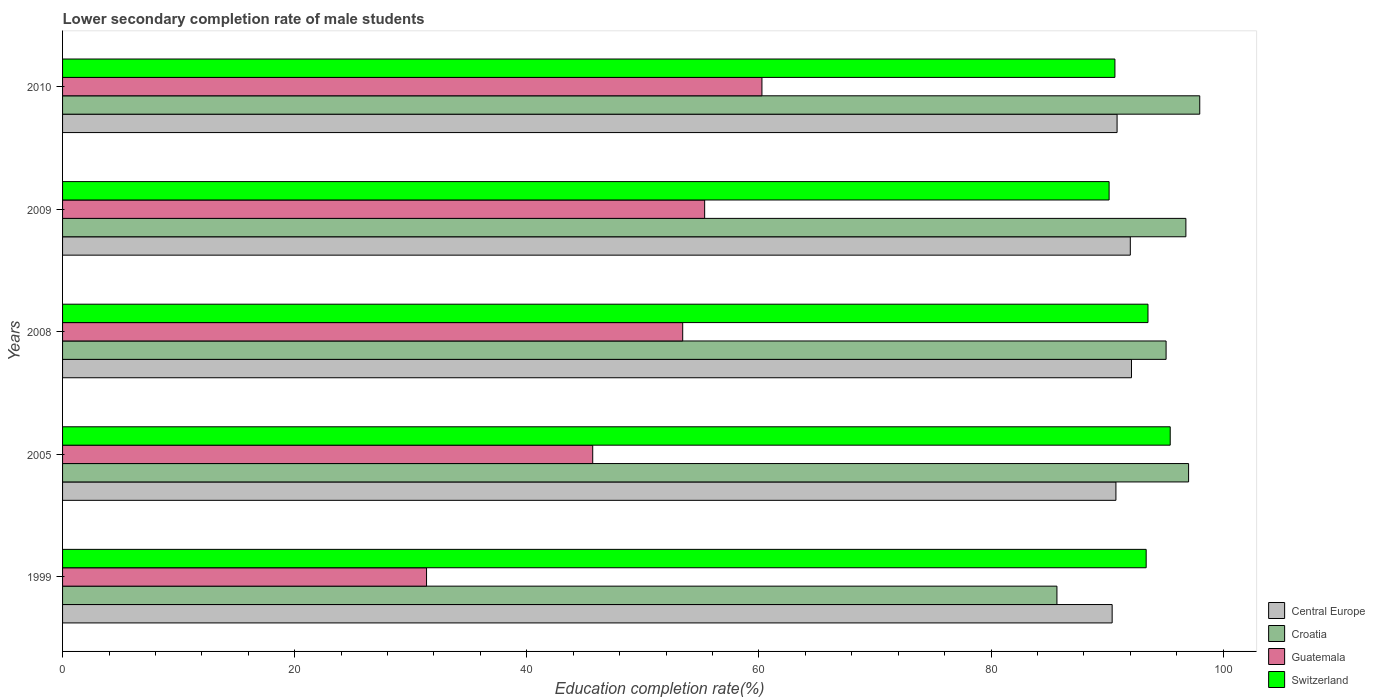How many groups of bars are there?
Your response must be concise. 5. Are the number of bars per tick equal to the number of legend labels?
Offer a terse response. Yes. How many bars are there on the 4th tick from the bottom?
Ensure brevity in your answer.  4. In how many cases, is the number of bars for a given year not equal to the number of legend labels?
Provide a short and direct response. 0. What is the lower secondary completion rate of male students in Switzerland in 2005?
Provide a succinct answer. 95.43. Across all years, what is the maximum lower secondary completion rate of male students in Croatia?
Provide a succinct answer. 97.98. Across all years, what is the minimum lower secondary completion rate of male students in Croatia?
Make the answer very short. 85.67. What is the total lower secondary completion rate of male students in Switzerland in the graph?
Ensure brevity in your answer.  463.14. What is the difference between the lower secondary completion rate of male students in Central Europe in 2009 and that in 2010?
Provide a short and direct response. 1.14. What is the difference between the lower secondary completion rate of male students in Guatemala in 2010 and the lower secondary completion rate of male students in Central Europe in 2008?
Keep it short and to the point. -31.84. What is the average lower secondary completion rate of male students in Central Europe per year?
Your answer should be very brief. 91.23. In the year 2008, what is the difference between the lower secondary completion rate of male students in Switzerland and lower secondary completion rate of male students in Guatemala?
Make the answer very short. 40.09. In how many years, is the lower secondary completion rate of male students in Croatia greater than 20 %?
Your answer should be compact. 5. What is the ratio of the lower secondary completion rate of male students in Central Europe in 1999 to that in 2005?
Offer a terse response. 1. Is the difference between the lower secondary completion rate of male students in Switzerland in 2005 and 2009 greater than the difference between the lower secondary completion rate of male students in Guatemala in 2005 and 2009?
Your answer should be very brief. Yes. What is the difference between the highest and the second highest lower secondary completion rate of male students in Switzerland?
Make the answer very short. 1.92. What is the difference between the highest and the lowest lower secondary completion rate of male students in Central Europe?
Provide a short and direct response. 1.67. In how many years, is the lower secondary completion rate of male students in Guatemala greater than the average lower secondary completion rate of male students in Guatemala taken over all years?
Make the answer very short. 3. Is the sum of the lower secondary completion rate of male students in Switzerland in 2005 and 2010 greater than the maximum lower secondary completion rate of male students in Guatemala across all years?
Your response must be concise. Yes. Is it the case that in every year, the sum of the lower secondary completion rate of male students in Croatia and lower secondary completion rate of male students in Guatemala is greater than the sum of lower secondary completion rate of male students in Switzerland and lower secondary completion rate of male students in Central Europe?
Offer a very short reply. Yes. What does the 1st bar from the top in 2005 represents?
Your answer should be very brief. Switzerland. What does the 4th bar from the bottom in 2008 represents?
Ensure brevity in your answer.  Switzerland. How many bars are there?
Keep it short and to the point. 20. How many years are there in the graph?
Keep it short and to the point. 5. What is the difference between two consecutive major ticks on the X-axis?
Give a very brief answer. 20. Does the graph contain any zero values?
Offer a terse response. No. Does the graph contain grids?
Your answer should be compact. No. How many legend labels are there?
Your response must be concise. 4. How are the legend labels stacked?
Give a very brief answer. Vertical. What is the title of the graph?
Make the answer very short. Lower secondary completion rate of male students. What is the label or title of the X-axis?
Provide a short and direct response. Education completion rate(%). What is the Education completion rate(%) in Central Europe in 1999?
Ensure brevity in your answer.  90.43. What is the Education completion rate(%) of Croatia in 1999?
Make the answer very short. 85.67. What is the Education completion rate(%) of Guatemala in 1999?
Your answer should be very brief. 31.36. What is the Education completion rate(%) of Switzerland in 1999?
Provide a succinct answer. 93.36. What is the Education completion rate(%) of Central Europe in 2005?
Provide a succinct answer. 90.75. What is the Education completion rate(%) of Croatia in 2005?
Provide a short and direct response. 97.02. What is the Education completion rate(%) of Guatemala in 2005?
Keep it short and to the point. 45.68. What is the Education completion rate(%) of Switzerland in 2005?
Ensure brevity in your answer.  95.43. What is the Education completion rate(%) in Central Europe in 2008?
Provide a short and direct response. 92.1. What is the Education completion rate(%) of Croatia in 2008?
Your response must be concise. 95.08. What is the Education completion rate(%) in Guatemala in 2008?
Your answer should be very brief. 53.43. What is the Education completion rate(%) of Switzerland in 2008?
Make the answer very short. 93.52. What is the Education completion rate(%) in Central Europe in 2009?
Keep it short and to the point. 91.99. What is the Education completion rate(%) of Croatia in 2009?
Give a very brief answer. 96.78. What is the Education completion rate(%) in Guatemala in 2009?
Ensure brevity in your answer.  55.32. What is the Education completion rate(%) in Switzerland in 2009?
Ensure brevity in your answer.  90.17. What is the Education completion rate(%) in Central Europe in 2010?
Give a very brief answer. 90.85. What is the Education completion rate(%) in Croatia in 2010?
Your answer should be compact. 97.98. What is the Education completion rate(%) of Guatemala in 2010?
Ensure brevity in your answer.  60.26. What is the Education completion rate(%) of Switzerland in 2010?
Give a very brief answer. 90.67. Across all years, what is the maximum Education completion rate(%) of Central Europe?
Provide a short and direct response. 92.1. Across all years, what is the maximum Education completion rate(%) in Croatia?
Give a very brief answer. 97.98. Across all years, what is the maximum Education completion rate(%) of Guatemala?
Make the answer very short. 60.26. Across all years, what is the maximum Education completion rate(%) of Switzerland?
Keep it short and to the point. 95.43. Across all years, what is the minimum Education completion rate(%) in Central Europe?
Ensure brevity in your answer.  90.43. Across all years, what is the minimum Education completion rate(%) of Croatia?
Provide a succinct answer. 85.67. Across all years, what is the minimum Education completion rate(%) of Guatemala?
Give a very brief answer. 31.36. Across all years, what is the minimum Education completion rate(%) in Switzerland?
Keep it short and to the point. 90.17. What is the total Education completion rate(%) of Central Europe in the graph?
Offer a terse response. 456.13. What is the total Education completion rate(%) in Croatia in the graph?
Offer a terse response. 472.52. What is the total Education completion rate(%) of Guatemala in the graph?
Make the answer very short. 246.04. What is the total Education completion rate(%) in Switzerland in the graph?
Make the answer very short. 463.14. What is the difference between the Education completion rate(%) of Central Europe in 1999 and that in 2005?
Offer a very short reply. -0.32. What is the difference between the Education completion rate(%) of Croatia in 1999 and that in 2005?
Your response must be concise. -11.34. What is the difference between the Education completion rate(%) in Guatemala in 1999 and that in 2005?
Your answer should be very brief. -14.32. What is the difference between the Education completion rate(%) of Switzerland in 1999 and that in 2005?
Give a very brief answer. -2.07. What is the difference between the Education completion rate(%) of Central Europe in 1999 and that in 2008?
Provide a short and direct response. -1.67. What is the difference between the Education completion rate(%) in Croatia in 1999 and that in 2008?
Offer a very short reply. -9.4. What is the difference between the Education completion rate(%) in Guatemala in 1999 and that in 2008?
Your answer should be very brief. -22.07. What is the difference between the Education completion rate(%) of Switzerland in 1999 and that in 2008?
Provide a succinct answer. -0.16. What is the difference between the Education completion rate(%) in Central Europe in 1999 and that in 2009?
Your response must be concise. -1.56. What is the difference between the Education completion rate(%) of Croatia in 1999 and that in 2009?
Your answer should be compact. -11.11. What is the difference between the Education completion rate(%) of Guatemala in 1999 and that in 2009?
Make the answer very short. -23.96. What is the difference between the Education completion rate(%) in Switzerland in 1999 and that in 2009?
Provide a short and direct response. 3.19. What is the difference between the Education completion rate(%) of Central Europe in 1999 and that in 2010?
Provide a short and direct response. -0.42. What is the difference between the Education completion rate(%) in Croatia in 1999 and that in 2010?
Offer a very short reply. -12.3. What is the difference between the Education completion rate(%) of Guatemala in 1999 and that in 2010?
Your answer should be compact. -28.9. What is the difference between the Education completion rate(%) in Switzerland in 1999 and that in 2010?
Give a very brief answer. 2.69. What is the difference between the Education completion rate(%) of Central Europe in 2005 and that in 2008?
Your answer should be very brief. -1.34. What is the difference between the Education completion rate(%) in Croatia in 2005 and that in 2008?
Provide a succinct answer. 1.94. What is the difference between the Education completion rate(%) in Guatemala in 2005 and that in 2008?
Your answer should be compact. -7.75. What is the difference between the Education completion rate(%) in Switzerland in 2005 and that in 2008?
Your answer should be very brief. 1.92. What is the difference between the Education completion rate(%) of Central Europe in 2005 and that in 2009?
Make the answer very short. -1.24. What is the difference between the Education completion rate(%) of Croatia in 2005 and that in 2009?
Provide a short and direct response. 0.23. What is the difference between the Education completion rate(%) of Guatemala in 2005 and that in 2009?
Provide a succinct answer. -9.64. What is the difference between the Education completion rate(%) in Switzerland in 2005 and that in 2009?
Ensure brevity in your answer.  5.27. What is the difference between the Education completion rate(%) in Central Europe in 2005 and that in 2010?
Your answer should be very brief. -0.1. What is the difference between the Education completion rate(%) of Croatia in 2005 and that in 2010?
Keep it short and to the point. -0.96. What is the difference between the Education completion rate(%) of Guatemala in 2005 and that in 2010?
Your answer should be compact. -14.58. What is the difference between the Education completion rate(%) of Switzerland in 2005 and that in 2010?
Your answer should be compact. 4.76. What is the difference between the Education completion rate(%) in Central Europe in 2008 and that in 2009?
Give a very brief answer. 0.1. What is the difference between the Education completion rate(%) of Croatia in 2008 and that in 2009?
Offer a very short reply. -1.71. What is the difference between the Education completion rate(%) of Guatemala in 2008 and that in 2009?
Provide a succinct answer. -1.89. What is the difference between the Education completion rate(%) of Switzerland in 2008 and that in 2009?
Offer a very short reply. 3.35. What is the difference between the Education completion rate(%) in Central Europe in 2008 and that in 2010?
Give a very brief answer. 1.24. What is the difference between the Education completion rate(%) in Croatia in 2008 and that in 2010?
Keep it short and to the point. -2.9. What is the difference between the Education completion rate(%) of Guatemala in 2008 and that in 2010?
Your response must be concise. -6.83. What is the difference between the Education completion rate(%) in Switzerland in 2008 and that in 2010?
Make the answer very short. 2.85. What is the difference between the Education completion rate(%) in Central Europe in 2009 and that in 2010?
Keep it short and to the point. 1.14. What is the difference between the Education completion rate(%) in Croatia in 2009 and that in 2010?
Make the answer very short. -1.19. What is the difference between the Education completion rate(%) of Guatemala in 2009 and that in 2010?
Ensure brevity in your answer.  -4.94. What is the difference between the Education completion rate(%) in Switzerland in 2009 and that in 2010?
Offer a very short reply. -0.5. What is the difference between the Education completion rate(%) in Central Europe in 1999 and the Education completion rate(%) in Croatia in 2005?
Keep it short and to the point. -6.59. What is the difference between the Education completion rate(%) in Central Europe in 1999 and the Education completion rate(%) in Guatemala in 2005?
Your answer should be very brief. 44.75. What is the difference between the Education completion rate(%) in Central Europe in 1999 and the Education completion rate(%) in Switzerland in 2005?
Ensure brevity in your answer.  -5. What is the difference between the Education completion rate(%) in Croatia in 1999 and the Education completion rate(%) in Guatemala in 2005?
Your response must be concise. 40. What is the difference between the Education completion rate(%) in Croatia in 1999 and the Education completion rate(%) in Switzerland in 2005?
Keep it short and to the point. -9.76. What is the difference between the Education completion rate(%) of Guatemala in 1999 and the Education completion rate(%) of Switzerland in 2005?
Provide a short and direct response. -64.07. What is the difference between the Education completion rate(%) in Central Europe in 1999 and the Education completion rate(%) in Croatia in 2008?
Offer a terse response. -4.65. What is the difference between the Education completion rate(%) in Central Europe in 1999 and the Education completion rate(%) in Guatemala in 2008?
Your answer should be very brief. 37. What is the difference between the Education completion rate(%) of Central Europe in 1999 and the Education completion rate(%) of Switzerland in 2008?
Offer a terse response. -3.09. What is the difference between the Education completion rate(%) of Croatia in 1999 and the Education completion rate(%) of Guatemala in 2008?
Make the answer very short. 32.24. What is the difference between the Education completion rate(%) in Croatia in 1999 and the Education completion rate(%) in Switzerland in 2008?
Provide a short and direct response. -7.84. What is the difference between the Education completion rate(%) of Guatemala in 1999 and the Education completion rate(%) of Switzerland in 2008?
Offer a terse response. -62.16. What is the difference between the Education completion rate(%) of Central Europe in 1999 and the Education completion rate(%) of Croatia in 2009?
Give a very brief answer. -6.35. What is the difference between the Education completion rate(%) in Central Europe in 1999 and the Education completion rate(%) in Guatemala in 2009?
Provide a short and direct response. 35.11. What is the difference between the Education completion rate(%) of Central Europe in 1999 and the Education completion rate(%) of Switzerland in 2009?
Give a very brief answer. 0.26. What is the difference between the Education completion rate(%) in Croatia in 1999 and the Education completion rate(%) in Guatemala in 2009?
Keep it short and to the point. 30.35. What is the difference between the Education completion rate(%) in Croatia in 1999 and the Education completion rate(%) in Switzerland in 2009?
Your answer should be very brief. -4.49. What is the difference between the Education completion rate(%) in Guatemala in 1999 and the Education completion rate(%) in Switzerland in 2009?
Your response must be concise. -58.81. What is the difference between the Education completion rate(%) of Central Europe in 1999 and the Education completion rate(%) of Croatia in 2010?
Give a very brief answer. -7.55. What is the difference between the Education completion rate(%) of Central Europe in 1999 and the Education completion rate(%) of Guatemala in 2010?
Your answer should be very brief. 30.17. What is the difference between the Education completion rate(%) in Central Europe in 1999 and the Education completion rate(%) in Switzerland in 2010?
Ensure brevity in your answer.  -0.24. What is the difference between the Education completion rate(%) of Croatia in 1999 and the Education completion rate(%) of Guatemala in 2010?
Your answer should be compact. 25.42. What is the difference between the Education completion rate(%) in Croatia in 1999 and the Education completion rate(%) in Switzerland in 2010?
Provide a succinct answer. -5. What is the difference between the Education completion rate(%) in Guatemala in 1999 and the Education completion rate(%) in Switzerland in 2010?
Your answer should be compact. -59.31. What is the difference between the Education completion rate(%) in Central Europe in 2005 and the Education completion rate(%) in Croatia in 2008?
Give a very brief answer. -4.32. What is the difference between the Education completion rate(%) of Central Europe in 2005 and the Education completion rate(%) of Guatemala in 2008?
Offer a very short reply. 37.32. What is the difference between the Education completion rate(%) of Central Europe in 2005 and the Education completion rate(%) of Switzerland in 2008?
Provide a short and direct response. -2.76. What is the difference between the Education completion rate(%) of Croatia in 2005 and the Education completion rate(%) of Guatemala in 2008?
Keep it short and to the point. 43.59. What is the difference between the Education completion rate(%) in Croatia in 2005 and the Education completion rate(%) in Switzerland in 2008?
Keep it short and to the point. 3.5. What is the difference between the Education completion rate(%) in Guatemala in 2005 and the Education completion rate(%) in Switzerland in 2008?
Give a very brief answer. -47.84. What is the difference between the Education completion rate(%) in Central Europe in 2005 and the Education completion rate(%) in Croatia in 2009?
Your response must be concise. -6.03. What is the difference between the Education completion rate(%) in Central Europe in 2005 and the Education completion rate(%) in Guatemala in 2009?
Provide a short and direct response. 35.43. What is the difference between the Education completion rate(%) in Central Europe in 2005 and the Education completion rate(%) in Switzerland in 2009?
Keep it short and to the point. 0.59. What is the difference between the Education completion rate(%) in Croatia in 2005 and the Education completion rate(%) in Guatemala in 2009?
Offer a very short reply. 41.69. What is the difference between the Education completion rate(%) of Croatia in 2005 and the Education completion rate(%) of Switzerland in 2009?
Your response must be concise. 6.85. What is the difference between the Education completion rate(%) of Guatemala in 2005 and the Education completion rate(%) of Switzerland in 2009?
Your answer should be compact. -44.49. What is the difference between the Education completion rate(%) of Central Europe in 2005 and the Education completion rate(%) of Croatia in 2010?
Offer a very short reply. -7.22. What is the difference between the Education completion rate(%) of Central Europe in 2005 and the Education completion rate(%) of Guatemala in 2010?
Your answer should be compact. 30.5. What is the difference between the Education completion rate(%) of Central Europe in 2005 and the Education completion rate(%) of Switzerland in 2010?
Give a very brief answer. 0.09. What is the difference between the Education completion rate(%) in Croatia in 2005 and the Education completion rate(%) in Guatemala in 2010?
Make the answer very short. 36.76. What is the difference between the Education completion rate(%) in Croatia in 2005 and the Education completion rate(%) in Switzerland in 2010?
Make the answer very short. 6.35. What is the difference between the Education completion rate(%) of Guatemala in 2005 and the Education completion rate(%) of Switzerland in 2010?
Your response must be concise. -44.99. What is the difference between the Education completion rate(%) of Central Europe in 2008 and the Education completion rate(%) of Croatia in 2009?
Provide a short and direct response. -4.69. What is the difference between the Education completion rate(%) of Central Europe in 2008 and the Education completion rate(%) of Guatemala in 2009?
Provide a short and direct response. 36.77. What is the difference between the Education completion rate(%) in Central Europe in 2008 and the Education completion rate(%) in Switzerland in 2009?
Provide a succinct answer. 1.93. What is the difference between the Education completion rate(%) of Croatia in 2008 and the Education completion rate(%) of Guatemala in 2009?
Provide a short and direct response. 39.76. What is the difference between the Education completion rate(%) in Croatia in 2008 and the Education completion rate(%) in Switzerland in 2009?
Give a very brief answer. 4.91. What is the difference between the Education completion rate(%) in Guatemala in 2008 and the Education completion rate(%) in Switzerland in 2009?
Offer a terse response. -36.74. What is the difference between the Education completion rate(%) in Central Europe in 2008 and the Education completion rate(%) in Croatia in 2010?
Provide a succinct answer. -5.88. What is the difference between the Education completion rate(%) in Central Europe in 2008 and the Education completion rate(%) in Guatemala in 2010?
Your answer should be compact. 31.84. What is the difference between the Education completion rate(%) of Central Europe in 2008 and the Education completion rate(%) of Switzerland in 2010?
Your answer should be very brief. 1.43. What is the difference between the Education completion rate(%) of Croatia in 2008 and the Education completion rate(%) of Guatemala in 2010?
Keep it short and to the point. 34.82. What is the difference between the Education completion rate(%) of Croatia in 2008 and the Education completion rate(%) of Switzerland in 2010?
Your answer should be very brief. 4.41. What is the difference between the Education completion rate(%) of Guatemala in 2008 and the Education completion rate(%) of Switzerland in 2010?
Make the answer very short. -37.24. What is the difference between the Education completion rate(%) of Central Europe in 2009 and the Education completion rate(%) of Croatia in 2010?
Give a very brief answer. -5.98. What is the difference between the Education completion rate(%) of Central Europe in 2009 and the Education completion rate(%) of Guatemala in 2010?
Give a very brief answer. 31.74. What is the difference between the Education completion rate(%) in Central Europe in 2009 and the Education completion rate(%) in Switzerland in 2010?
Keep it short and to the point. 1.33. What is the difference between the Education completion rate(%) of Croatia in 2009 and the Education completion rate(%) of Guatemala in 2010?
Offer a very short reply. 36.53. What is the difference between the Education completion rate(%) of Croatia in 2009 and the Education completion rate(%) of Switzerland in 2010?
Your response must be concise. 6.11. What is the difference between the Education completion rate(%) in Guatemala in 2009 and the Education completion rate(%) in Switzerland in 2010?
Keep it short and to the point. -35.35. What is the average Education completion rate(%) of Central Europe per year?
Give a very brief answer. 91.22. What is the average Education completion rate(%) of Croatia per year?
Provide a short and direct response. 94.5. What is the average Education completion rate(%) of Guatemala per year?
Keep it short and to the point. 49.21. What is the average Education completion rate(%) of Switzerland per year?
Offer a terse response. 92.63. In the year 1999, what is the difference between the Education completion rate(%) of Central Europe and Education completion rate(%) of Croatia?
Your response must be concise. 4.76. In the year 1999, what is the difference between the Education completion rate(%) in Central Europe and Education completion rate(%) in Guatemala?
Give a very brief answer. 59.07. In the year 1999, what is the difference between the Education completion rate(%) in Central Europe and Education completion rate(%) in Switzerland?
Offer a terse response. -2.93. In the year 1999, what is the difference between the Education completion rate(%) in Croatia and Education completion rate(%) in Guatemala?
Keep it short and to the point. 54.31. In the year 1999, what is the difference between the Education completion rate(%) of Croatia and Education completion rate(%) of Switzerland?
Make the answer very short. -7.69. In the year 1999, what is the difference between the Education completion rate(%) in Guatemala and Education completion rate(%) in Switzerland?
Your answer should be compact. -62. In the year 2005, what is the difference between the Education completion rate(%) in Central Europe and Education completion rate(%) in Croatia?
Ensure brevity in your answer.  -6.26. In the year 2005, what is the difference between the Education completion rate(%) in Central Europe and Education completion rate(%) in Guatemala?
Offer a terse response. 45.08. In the year 2005, what is the difference between the Education completion rate(%) in Central Europe and Education completion rate(%) in Switzerland?
Your response must be concise. -4.68. In the year 2005, what is the difference between the Education completion rate(%) in Croatia and Education completion rate(%) in Guatemala?
Offer a very short reply. 51.34. In the year 2005, what is the difference between the Education completion rate(%) in Croatia and Education completion rate(%) in Switzerland?
Make the answer very short. 1.58. In the year 2005, what is the difference between the Education completion rate(%) of Guatemala and Education completion rate(%) of Switzerland?
Give a very brief answer. -49.76. In the year 2008, what is the difference between the Education completion rate(%) of Central Europe and Education completion rate(%) of Croatia?
Your response must be concise. -2.98. In the year 2008, what is the difference between the Education completion rate(%) in Central Europe and Education completion rate(%) in Guatemala?
Provide a succinct answer. 38.67. In the year 2008, what is the difference between the Education completion rate(%) of Central Europe and Education completion rate(%) of Switzerland?
Your response must be concise. -1.42. In the year 2008, what is the difference between the Education completion rate(%) in Croatia and Education completion rate(%) in Guatemala?
Your answer should be compact. 41.65. In the year 2008, what is the difference between the Education completion rate(%) in Croatia and Education completion rate(%) in Switzerland?
Provide a short and direct response. 1.56. In the year 2008, what is the difference between the Education completion rate(%) of Guatemala and Education completion rate(%) of Switzerland?
Offer a very short reply. -40.09. In the year 2009, what is the difference between the Education completion rate(%) in Central Europe and Education completion rate(%) in Croatia?
Keep it short and to the point. -4.79. In the year 2009, what is the difference between the Education completion rate(%) in Central Europe and Education completion rate(%) in Guatemala?
Make the answer very short. 36.67. In the year 2009, what is the difference between the Education completion rate(%) of Central Europe and Education completion rate(%) of Switzerland?
Offer a terse response. 1.83. In the year 2009, what is the difference between the Education completion rate(%) in Croatia and Education completion rate(%) in Guatemala?
Your answer should be compact. 41.46. In the year 2009, what is the difference between the Education completion rate(%) of Croatia and Education completion rate(%) of Switzerland?
Give a very brief answer. 6.62. In the year 2009, what is the difference between the Education completion rate(%) of Guatemala and Education completion rate(%) of Switzerland?
Offer a very short reply. -34.85. In the year 2010, what is the difference between the Education completion rate(%) in Central Europe and Education completion rate(%) in Croatia?
Provide a succinct answer. -7.12. In the year 2010, what is the difference between the Education completion rate(%) in Central Europe and Education completion rate(%) in Guatemala?
Give a very brief answer. 30.6. In the year 2010, what is the difference between the Education completion rate(%) in Central Europe and Education completion rate(%) in Switzerland?
Ensure brevity in your answer.  0.19. In the year 2010, what is the difference between the Education completion rate(%) in Croatia and Education completion rate(%) in Guatemala?
Offer a terse response. 37.72. In the year 2010, what is the difference between the Education completion rate(%) in Croatia and Education completion rate(%) in Switzerland?
Offer a very short reply. 7.31. In the year 2010, what is the difference between the Education completion rate(%) in Guatemala and Education completion rate(%) in Switzerland?
Give a very brief answer. -30.41. What is the ratio of the Education completion rate(%) in Central Europe in 1999 to that in 2005?
Your response must be concise. 1. What is the ratio of the Education completion rate(%) in Croatia in 1999 to that in 2005?
Ensure brevity in your answer.  0.88. What is the ratio of the Education completion rate(%) in Guatemala in 1999 to that in 2005?
Provide a succinct answer. 0.69. What is the ratio of the Education completion rate(%) of Switzerland in 1999 to that in 2005?
Offer a terse response. 0.98. What is the ratio of the Education completion rate(%) in Central Europe in 1999 to that in 2008?
Give a very brief answer. 0.98. What is the ratio of the Education completion rate(%) of Croatia in 1999 to that in 2008?
Offer a very short reply. 0.9. What is the ratio of the Education completion rate(%) of Guatemala in 1999 to that in 2008?
Your answer should be compact. 0.59. What is the ratio of the Education completion rate(%) in Switzerland in 1999 to that in 2008?
Your answer should be very brief. 1. What is the ratio of the Education completion rate(%) in Croatia in 1999 to that in 2009?
Make the answer very short. 0.89. What is the ratio of the Education completion rate(%) of Guatemala in 1999 to that in 2009?
Provide a succinct answer. 0.57. What is the ratio of the Education completion rate(%) in Switzerland in 1999 to that in 2009?
Give a very brief answer. 1.04. What is the ratio of the Education completion rate(%) of Central Europe in 1999 to that in 2010?
Give a very brief answer. 1. What is the ratio of the Education completion rate(%) of Croatia in 1999 to that in 2010?
Ensure brevity in your answer.  0.87. What is the ratio of the Education completion rate(%) in Guatemala in 1999 to that in 2010?
Provide a short and direct response. 0.52. What is the ratio of the Education completion rate(%) of Switzerland in 1999 to that in 2010?
Make the answer very short. 1.03. What is the ratio of the Education completion rate(%) in Central Europe in 2005 to that in 2008?
Make the answer very short. 0.99. What is the ratio of the Education completion rate(%) of Croatia in 2005 to that in 2008?
Ensure brevity in your answer.  1.02. What is the ratio of the Education completion rate(%) in Guatemala in 2005 to that in 2008?
Your answer should be very brief. 0.85. What is the ratio of the Education completion rate(%) of Switzerland in 2005 to that in 2008?
Ensure brevity in your answer.  1.02. What is the ratio of the Education completion rate(%) of Central Europe in 2005 to that in 2009?
Give a very brief answer. 0.99. What is the ratio of the Education completion rate(%) of Guatemala in 2005 to that in 2009?
Ensure brevity in your answer.  0.83. What is the ratio of the Education completion rate(%) of Switzerland in 2005 to that in 2009?
Provide a succinct answer. 1.06. What is the ratio of the Education completion rate(%) in Central Europe in 2005 to that in 2010?
Offer a terse response. 1. What is the ratio of the Education completion rate(%) of Croatia in 2005 to that in 2010?
Provide a short and direct response. 0.99. What is the ratio of the Education completion rate(%) of Guatemala in 2005 to that in 2010?
Provide a short and direct response. 0.76. What is the ratio of the Education completion rate(%) of Switzerland in 2005 to that in 2010?
Provide a short and direct response. 1.05. What is the ratio of the Education completion rate(%) of Central Europe in 2008 to that in 2009?
Give a very brief answer. 1. What is the ratio of the Education completion rate(%) of Croatia in 2008 to that in 2009?
Keep it short and to the point. 0.98. What is the ratio of the Education completion rate(%) of Guatemala in 2008 to that in 2009?
Give a very brief answer. 0.97. What is the ratio of the Education completion rate(%) of Switzerland in 2008 to that in 2009?
Offer a terse response. 1.04. What is the ratio of the Education completion rate(%) of Central Europe in 2008 to that in 2010?
Provide a short and direct response. 1.01. What is the ratio of the Education completion rate(%) in Croatia in 2008 to that in 2010?
Provide a succinct answer. 0.97. What is the ratio of the Education completion rate(%) of Guatemala in 2008 to that in 2010?
Make the answer very short. 0.89. What is the ratio of the Education completion rate(%) in Switzerland in 2008 to that in 2010?
Provide a short and direct response. 1.03. What is the ratio of the Education completion rate(%) of Central Europe in 2009 to that in 2010?
Your response must be concise. 1.01. What is the ratio of the Education completion rate(%) in Guatemala in 2009 to that in 2010?
Make the answer very short. 0.92. What is the difference between the highest and the second highest Education completion rate(%) of Central Europe?
Offer a terse response. 0.1. What is the difference between the highest and the second highest Education completion rate(%) in Croatia?
Your answer should be very brief. 0.96. What is the difference between the highest and the second highest Education completion rate(%) of Guatemala?
Provide a short and direct response. 4.94. What is the difference between the highest and the second highest Education completion rate(%) of Switzerland?
Your response must be concise. 1.92. What is the difference between the highest and the lowest Education completion rate(%) of Central Europe?
Offer a very short reply. 1.67. What is the difference between the highest and the lowest Education completion rate(%) in Croatia?
Give a very brief answer. 12.3. What is the difference between the highest and the lowest Education completion rate(%) in Guatemala?
Make the answer very short. 28.9. What is the difference between the highest and the lowest Education completion rate(%) in Switzerland?
Your response must be concise. 5.27. 